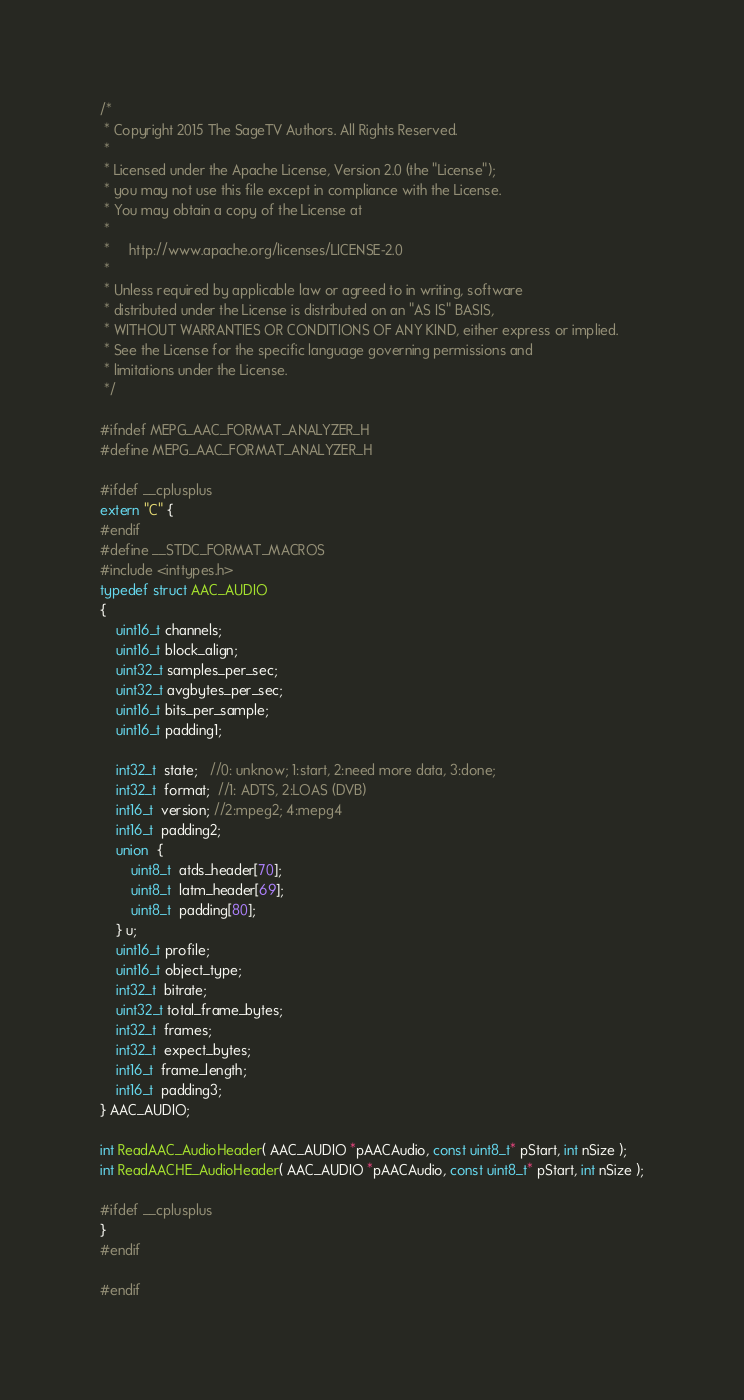Convert code to text. <code><loc_0><loc_0><loc_500><loc_500><_C_>/*
 * Copyright 2015 The SageTV Authors. All Rights Reserved.
 *
 * Licensed under the Apache License, Version 2.0 (the "License");
 * you may not use this file except in compliance with the License.
 * You may obtain a copy of the License at
 *
 *     http://www.apache.org/licenses/LICENSE-2.0
 *
 * Unless required by applicable law or agreed to in writing, software
 * distributed under the License is distributed on an "AS IS" BASIS,
 * WITHOUT WARRANTIES OR CONDITIONS OF ANY KIND, either express or implied.
 * See the License for the specific language governing permissions and
 * limitations under the License.
 */

#ifndef MEPG_AAC_FORMAT_ANALYZER_H
#define MEPG_AAC_FORMAT_ANALYZER_H

#ifdef __cplusplus
extern "C" {
#endif
#define __STDC_FORMAT_MACROS
#include <inttypes.h>
typedef struct AAC_AUDIO
{
	uint16_t channels;
	uint16_t block_align;
	uint32_t samples_per_sec;
	uint32_t avgbytes_per_sec;
	uint16_t bits_per_sample;
	uint16_t padding1;

	int32_t  state;   //0: unknow; 1:start, 2:need more data, 3:done;
	int32_t  format;  //1: ADTS, 2:LOAS (DVB)
	int16_t  version; //2:mpeg2; 4:mepg4
	int16_t  padding2;
	union  {
		uint8_t  atds_header[70];
		uint8_t  latm_header[69];
		uint8_t  padding[80];
	} u;
	uint16_t profile;
	uint16_t object_type;
	int32_t  bitrate;
	uint32_t total_frame_bytes;
	int32_t  frames;
	int32_t  expect_bytes;
	int16_t  frame_length;
	int16_t  padding3;
} AAC_AUDIO;

int ReadAAC_AudioHeader( AAC_AUDIO *pAACAudio, const uint8_t* pStart, int nSize );
int ReadAACHE_AudioHeader( AAC_AUDIO *pAACAudio, const uint8_t* pStart, int nSize );

#ifdef __cplusplus
}
#endif

#endif
</code> 